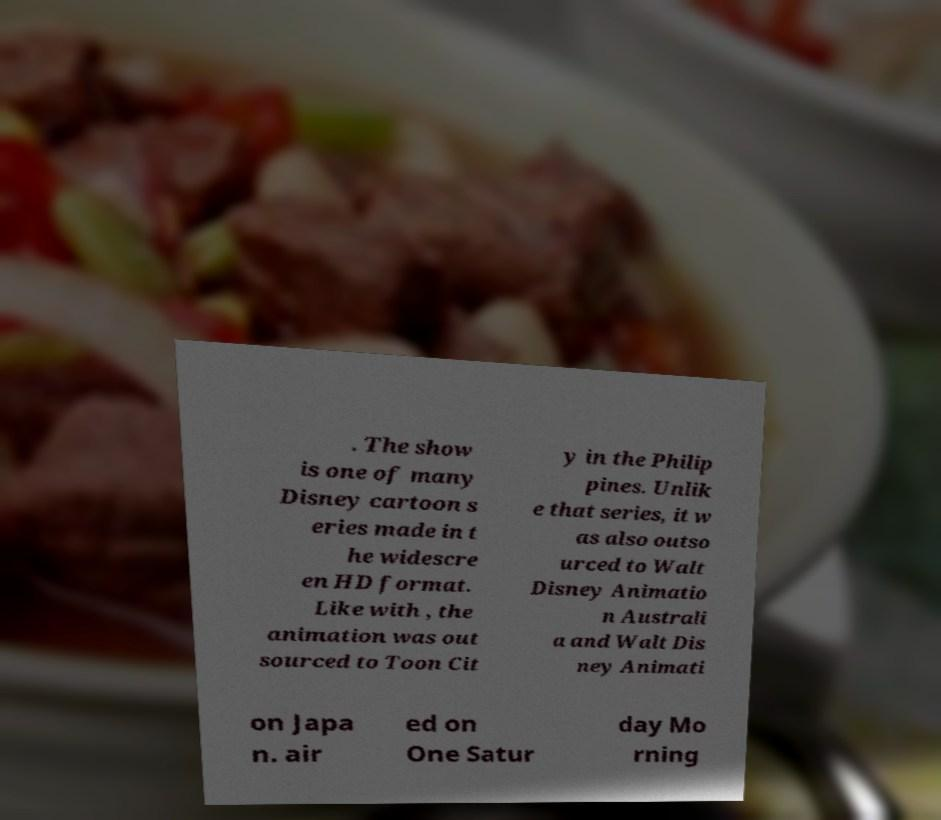Could you assist in decoding the text presented in this image and type it out clearly? . The show is one of many Disney cartoon s eries made in t he widescre en HD format. Like with , the animation was out sourced to Toon Cit y in the Philip pines. Unlik e that series, it w as also outso urced to Walt Disney Animatio n Australi a and Walt Dis ney Animati on Japa n. air ed on One Satur day Mo rning 